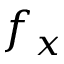Convert formula to latex. <formula><loc_0><loc_0><loc_500><loc_500>f _ { x }</formula> 